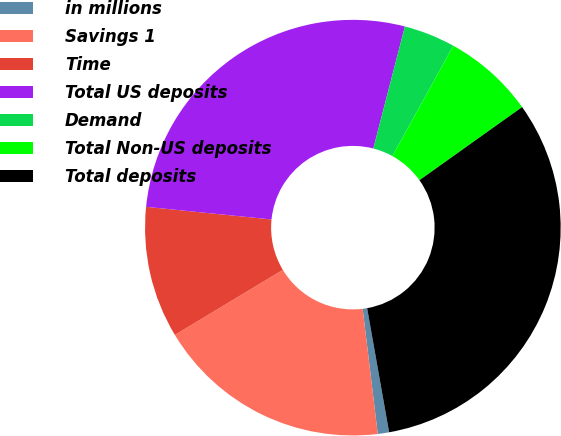Convert chart. <chart><loc_0><loc_0><loc_500><loc_500><pie_chart><fcel>in millions<fcel>Savings 1<fcel>Time<fcel>Total US deposits<fcel>Demand<fcel>Total Non-US deposits<fcel>Total deposits<nl><fcel>0.88%<fcel>18.28%<fcel>10.23%<fcel>27.43%<fcel>4.0%<fcel>7.12%<fcel>32.06%<nl></chart> 